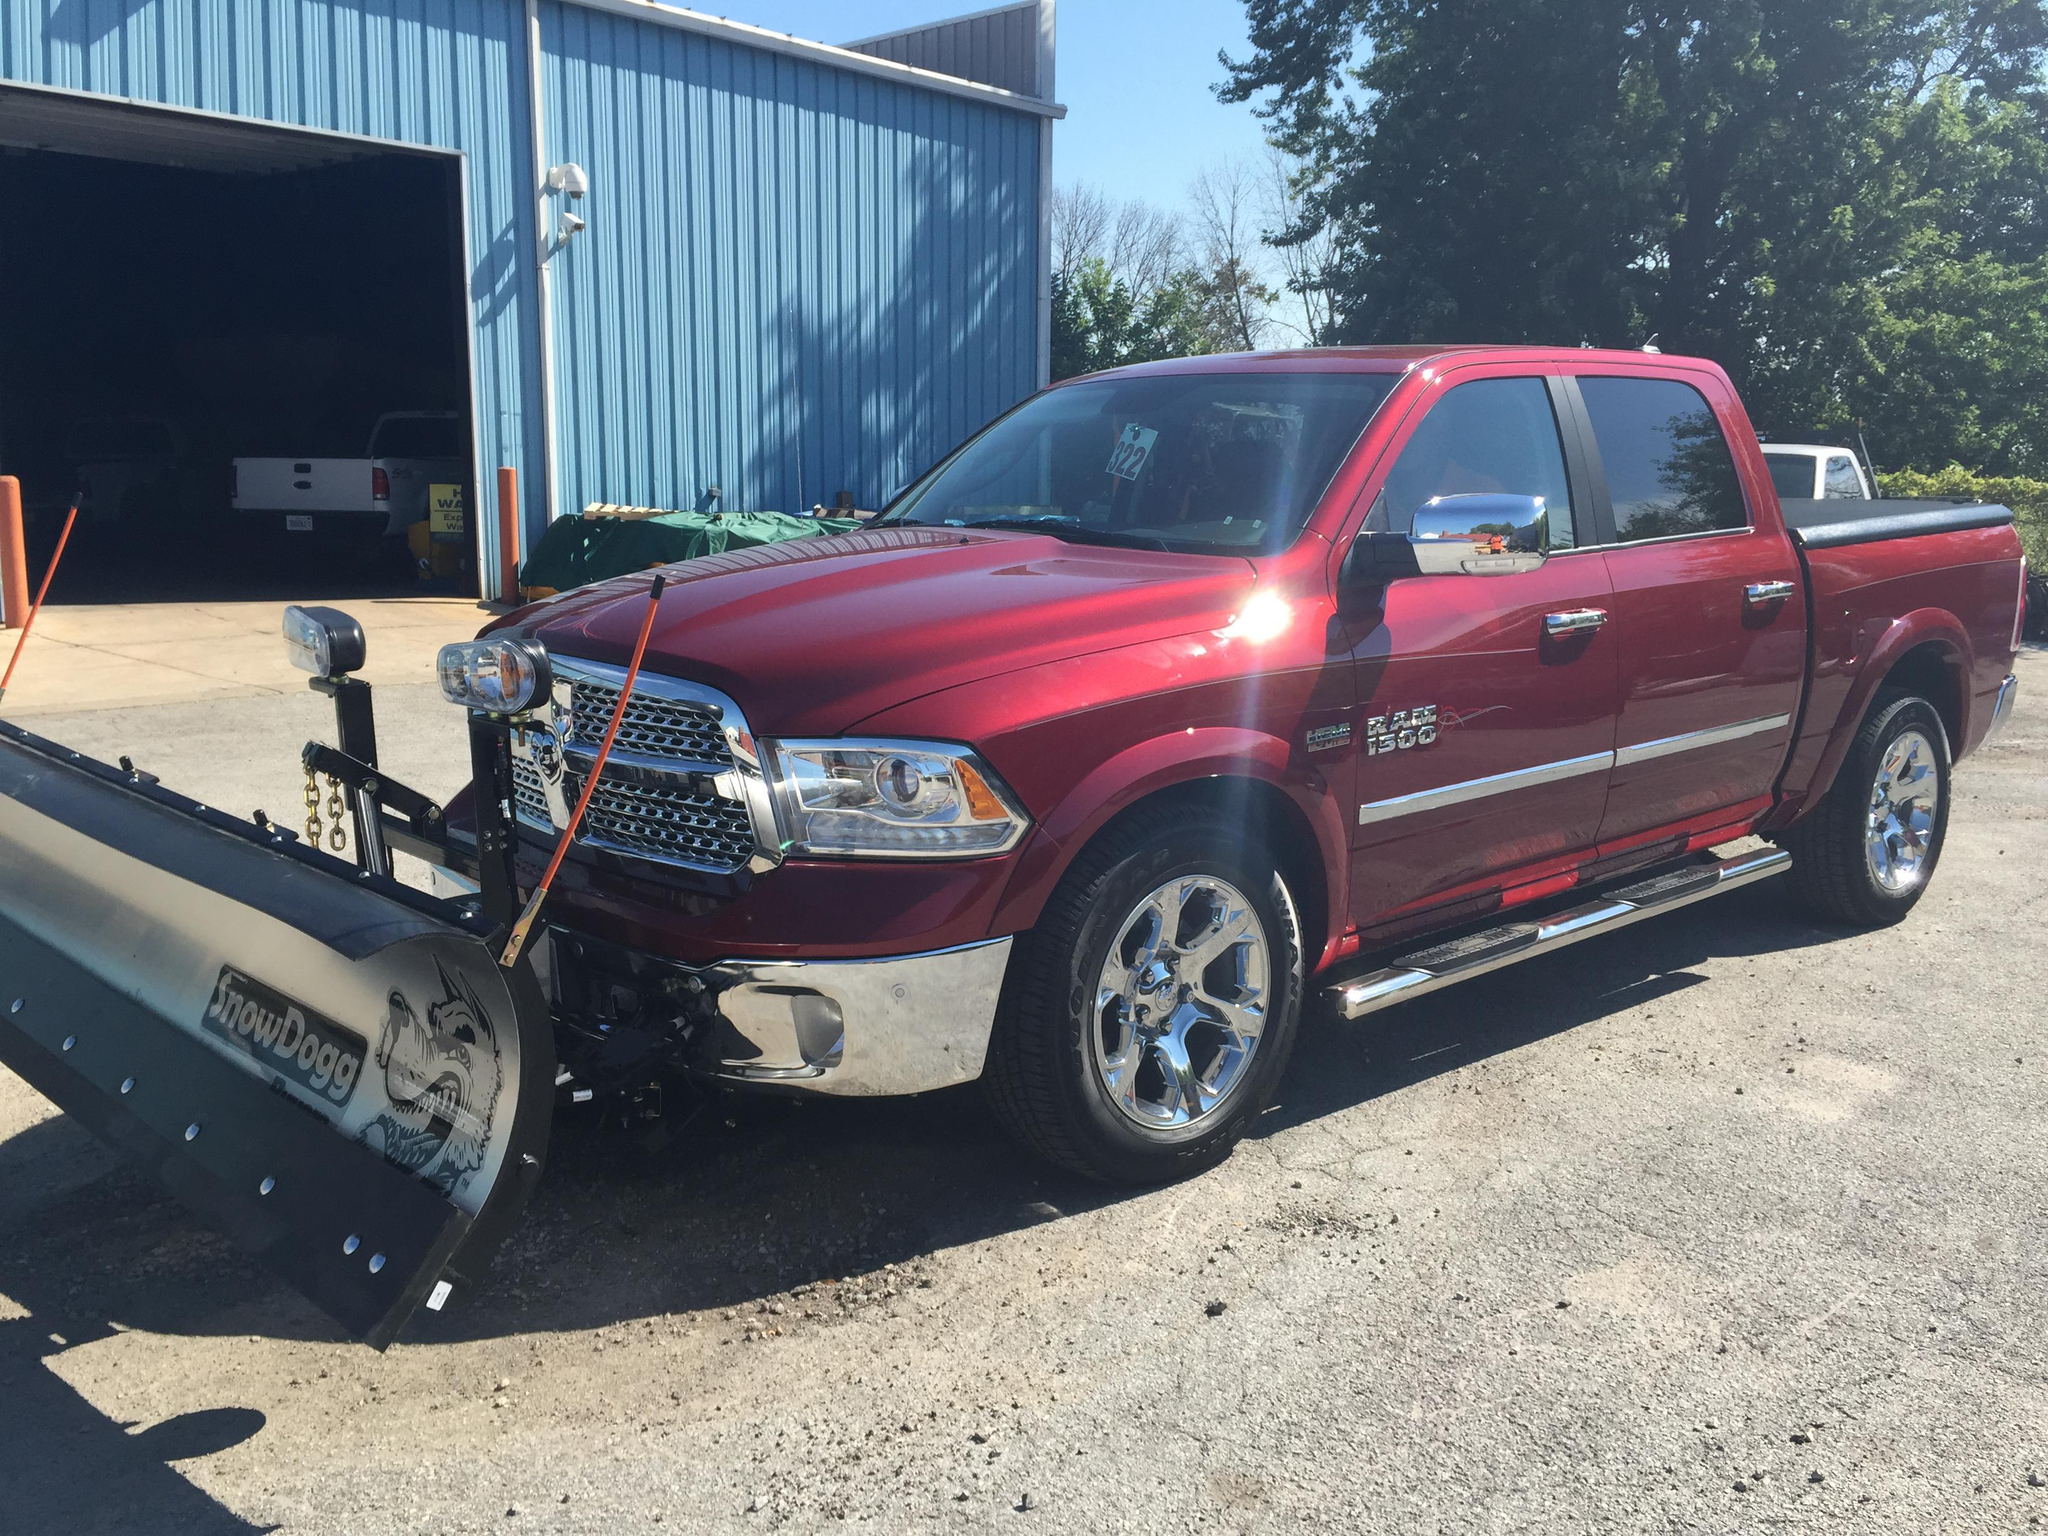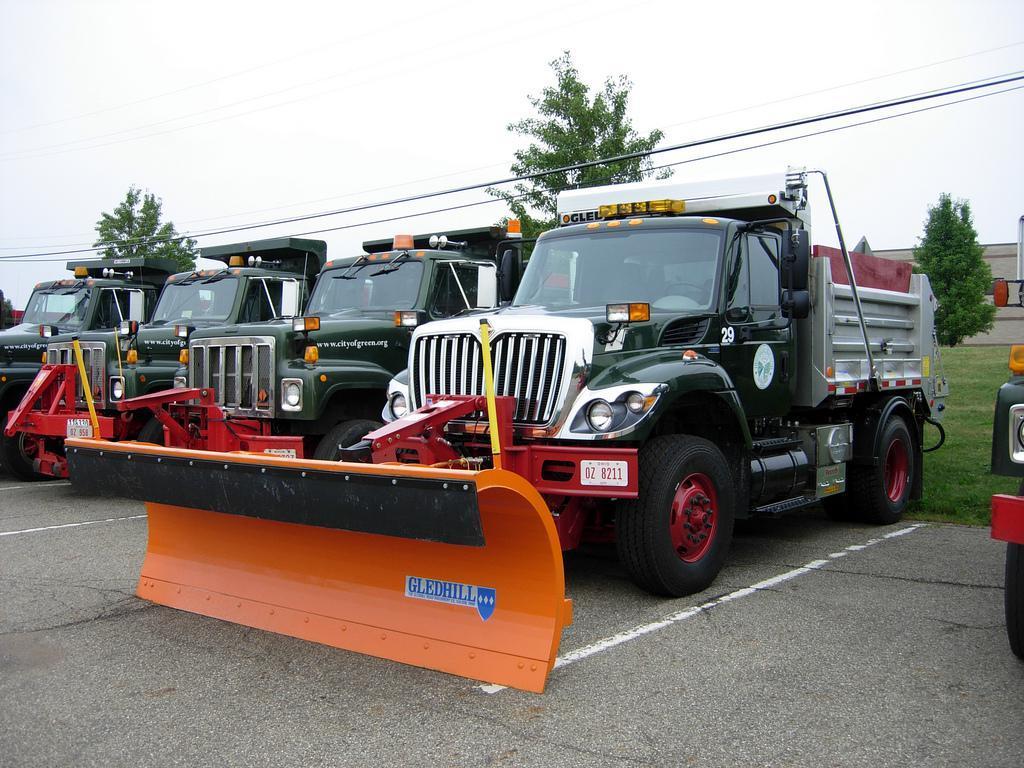The first image is the image on the left, the second image is the image on the right. Evaluate the accuracy of this statement regarding the images: "A truck is red.". Is it true? Answer yes or no. Yes. The first image is the image on the left, the second image is the image on the right. Evaluate the accuracy of this statement regarding the images: "At least one of the plows is made up of two separate panels with a gap between them.". Is it true? Answer yes or no. No. 